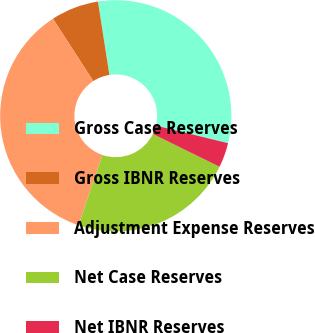Convert chart. <chart><loc_0><loc_0><loc_500><loc_500><pie_chart><fcel>Gross Case Reserves<fcel>Gross IBNR Reserves<fcel>Adjustment Expense Reserves<fcel>Net Case Reserves<fcel>Net IBNR Reserves<nl><fcel>31.26%<fcel>6.68%<fcel>35.63%<fcel>22.96%<fcel>3.46%<nl></chart> 